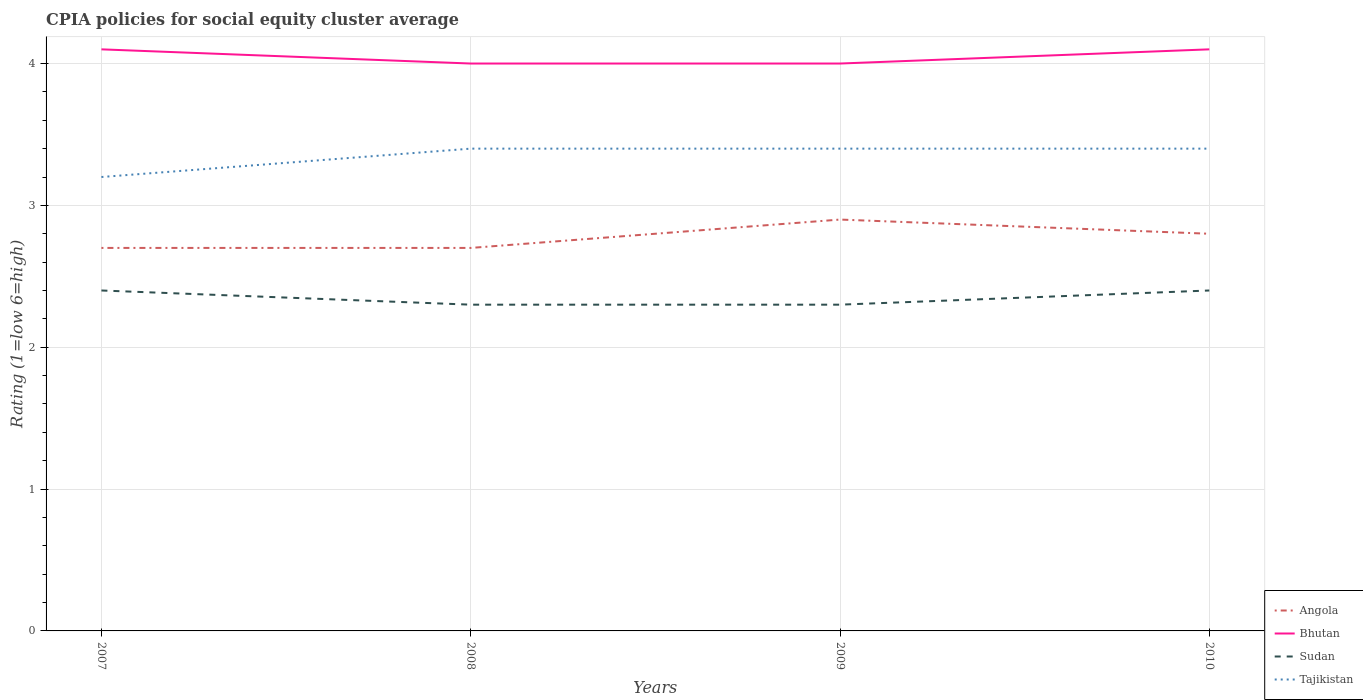How many different coloured lines are there?
Your answer should be compact. 4. Across all years, what is the maximum CPIA rating in Sudan?
Provide a short and direct response. 2.3. What is the total CPIA rating in Angola in the graph?
Make the answer very short. 0. What is the difference between the highest and the second highest CPIA rating in Tajikistan?
Give a very brief answer. 0.2. Is the CPIA rating in Bhutan strictly greater than the CPIA rating in Tajikistan over the years?
Your answer should be very brief. No. Are the values on the major ticks of Y-axis written in scientific E-notation?
Offer a terse response. No. Does the graph contain any zero values?
Your response must be concise. No. Does the graph contain grids?
Ensure brevity in your answer.  Yes. Where does the legend appear in the graph?
Provide a short and direct response. Bottom right. How many legend labels are there?
Your response must be concise. 4. How are the legend labels stacked?
Your answer should be compact. Vertical. What is the title of the graph?
Provide a short and direct response. CPIA policies for social equity cluster average. Does "Ukraine" appear as one of the legend labels in the graph?
Your response must be concise. No. What is the Rating (1=low 6=high) of Sudan in 2007?
Ensure brevity in your answer.  2.4. What is the Rating (1=low 6=high) in Tajikistan in 2007?
Your response must be concise. 3.2. What is the Rating (1=low 6=high) of Bhutan in 2008?
Give a very brief answer. 4. What is the Rating (1=low 6=high) in Sudan in 2008?
Offer a very short reply. 2.3. What is the Rating (1=low 6=high) in Tajikistan in 2008?
Keep it short and to the point. 3.4. What is the Rating (1=low 6=high) in Tajikistan in 2009?
Your answer should be very brief. 3.4. What is the Rating (1=low 6=high) of Angola in 2010?
Your response must be concise. 2.8. What is the Rating (1=low 6=high) of Bhutan in 2010?
Ensure brevity in your answer.  4.1. Across all years, what is the maximum Rating (1=low 6=high) in Angola?
Make the answer very short. 2.9. Across all years, what is the maximum Rating (1=low 6=high) in Bhutan?
Keep it short and to the point. 4.1. Across all years, what is the maximum Rating (1=low 6=high) of Tajikistan?
Ensure brevity in your answer.  3.4. Across all years, what is the minimum Rating (1=low 6=high) in Bhutan?
Keep it short and to the point. 4. Across all years, what is the minimum Rating (1=low 6=high) in Sudan?
Your answer should be compact. 2.3. What is the total Rating (1=low 6=high) of Angola in the graph?
Make the answer very short. 11.1. What is the total Rating (1=low 6=high) in Bhutan in the graph?
Your answer should be compact. 16.2. What is the difference between the Rating (1=low 6=high) in Bhutan in 2007 and that in 2008?
Provide a succinct answer. 0.1. What is the difference between the Rating (1=low 6=high) in Tajikistan in 2007 and that in 2008?
Your answer should be very brief. -0.2. What is the difference between the Rating (1=low 6=high) in Bhutan in 2007 and that in 2009?
Keep it short and to the point. 0.1. What is the difference between the Rating (1=low 6=high) in Sudan in 2007 and that in 2009?
Your answer should be compact. 0.1. What is the difference between the Rating (1=low 6=high) of Sudan in 2007 and that in 2010?
Keep it short and to the point. 0. What is the difference between the Rating (1=low 6=high) in Tajikistan in 2007 and that in 2010?
Provide a short and direct response. -0.2. What is the difference between the Rating (1=low 6=high) in Angola in 2008 and that in 2009?
Offer a terse response. -0.2. What is the difference between the Rating (1=low 6=high) of Sudan in 2008 and that in 2010?
Provide a short and direct response. -0.1. What is the difference between the Rating (1=low 6=high) in Tajikistan in 2008 and that in 2010?
Your answer should be compact. 0. What is the difference between the Rating (1=low 6=high) of Angola in 2009 and that in 2010?
Your response must be concise. 0.1. What is the difference between the Rating (1=low 6=high) in Bhutan in 2009 and that in 2010?
Your answer should be compact. -0.1. What is the difference between the Rating (1=low 6=high) in Sudan in 2009 and that in 2010?
Your answer should be compact. -0.1. What is the difference between the Rating (1=low 6=high) of Tajikistan in 2009 and that in 2010?
Provide a succinct answer. 0. What is the difference between the Rating (1=low 6=high) in Angola in 2007 and the Rating (1=low 6=high) in Sudan in 2008?
Your answer should be compact. 0.4. What is the difference between the Rating (1=low 6=high) in Bhutan in 2007 and the Rating (1=low 6=high) in Sudan in 2008?
Keep it short and to the point. 1.8. What is the difference between the Rating (1=low 6=high) in Bhutan in 2007 and the Rating (1=low 6=high) in Tajikistan in 2008?
Your answer should be very brief. 0.7. What is the difference between the Rating (1=low 6=high) of Angola in 2007 and the Rating (1=low 6=high) of Bhutan in 2009?
Keep it short and to the point. -1.3. What is the difference between the Rating (1=low 6=high) of Angola in 2007 and the Rating (1=low 6=high) of Tajikistan in 2009?
Give a very brief answer. -0.7. What is the difference between the Rating (1=low 6=high) of Sudan in 2007 and the Rating (1=low 6=high) of Tajikistan in 2009?
Make the answer very short. -1. What is the difference between the Rating (1=low 6=high) in Angola in 2007 and the Rating (1=low 6=high) in Bhutan in 2010?
Provide a short and direct response. -1.4. What is the difference between the Rating (1=low 6=high) in Angola in 2007 and the Rating (1=low 6=high) in Sudan in 2010?
Your response must be concise. 0.3. What is the difference between the Rating (1=low 6=high) of Angola in 2007 and the Rating (1=low 6=high) of Tajikistan in 2010?
Provide a short and direct response. -0.7. What is the difference between the Rating (1=low 6=high) in Bhutan in 2007 and the Rating (1=low 6=high) in Sudan in 2010?
Give a very brief answer. 1.7. What is the difference between the Rating (1=low 6=high) in Bhutan in 2007 and the Rating (1=low 6=high) in Tajikistan in 2010?
Your answer should be very brief. 0.7. What is the difference between the Rating (1=low 6=high) in Angola in 2008 and the Rating (1=low 6=high) in Bhutan in 2009?
Give a very brief answer. -1.3. What is the difference between the Rating (1=low 6=high) in Angola in 2008 and the Rating (1=low 6=high) in Tajikistan in 2009?
Make the answer very short. -0.7. What is the difference between the Rating (1=low 6=high) of Bhutan in 2008 and the Rating (1=low 6=high) of Sudan in 2009?
Give a very brief answer. 1.7. What is the difference between the Rating (1=low 6=high) of Bhutan in 2008 and the Rating (1=low 6=high) of Tajikistan in 2009?
Your response must be concise. 0.6. What is the difference between the Rating (1=low 6=high) in Sudan in 2008 and the Rating (1=low 6=high) in Tajikistan in 2009?
Your answer should be compact. -1.1. What is the difference between the Rating (1=low 6=high) in Angola in 2008 and the Rating (1=low 6=high) in Bhutan in 2010?
Your answer should be compact. -1.4. What is the difference between the Rating (1=low 6=high) of Angola in 2008 and the Rating (1=low 6=high) of Tajikistan in 2010?
Your answer should be compact. -0.7. What is the difference between the Rating (1=low 6=high) in Bhutan in 2008 and the Rating (1=low 6=high) in Sudan in 2010?
Your response must be concise. 1.6. What is the difference between the Rating (1=low 6=high) in Bhutan in 2008 and the Rating (1=low 6=high) in Tajikistan in 2010?
Your answer should be compact. 0.6. What is the difference between the Rating (1=low 6=high) in Sudan in 2008 and the Rating (1=low 6=high) in Tajikistan in 2010?
Keep it short and to the point. -1.1. What is the difference between the Rating (1=low 6=high) of Angola in 2009 and the Rating (1=low 6=high) of Sudan in 2010?
Give a very brief answer. 0.5. What is the difference between the Rating (1=low 6=high) of Bhutan in 2009 and the Rating (1=low 6=high) of Sudan in 2010?
Your answer should be compact. 1.6. What is the difference between the Rating (1=low 6=high) in Bhutan in 2009 and the Rating (1=low 6=high) in Tajikistan in 2010?
Ensure brevity in your answer.  0.6. What is the difference between the Rating (1=low 6=high) of Sudan in 2009 and the Rating (1=low 6=high) of Tajikistan in 2010?
Offer a very short reply. -1.1. What is the average Rating (1=low 6=high) of Angola per year?
Offer a terse response. 2.77. What is the average Rating (1=low 6=high) of Bhutan per year?
Provide a succinct answer. 4.05. What is the average Rating (1=low 6=high) of Sudan per year?
Provide a short and direct response. 2.35. What is the average Rating (1=low 6=high) of Tajikistan per year?
Give a very brief answer. 3.35. In the year 2007, what is the difference between the Rating (1=low 6=high) of Angola and Rating (1=low 6=high) of Bhutan?
Offer a very short reply. -1.4. In the year 2007, what is the difference between the Rating (1=low 6=high) in Angola and Rating (1=low 6=high) in Sudan?
Your answer should be very brief. 0.3. In the year 2007, what is the difference between the Rating (1=low 6=high) in Angola and Rating (1=low 6=high) in Tajikistan?
Your response must be concise. -0.5. In the year 2007, what is the difference between the Rating (1=low 6=high) of Bhutan and Rating (1=low 6=high) of Tajikistan?
Give a very brief answer. 0.9. In the year 2008, what is the difference between the Rating (1=low 6=high) in Angola and Rating (1=low 6=high) in Bhutan?
Your answer should be very brief. -1.3. In the year 2008, what is the difference between the Rating (1=low 6=high) of Angola and Rating (1=low 6=high) of Sudan?
Your response must be concise. 0.4. In the year 2008, what is the difference between the Rating (1=low 6=high) in Angola and Rating (1=low 6=high) in Tajikistan?
Your answer should be compact. -0.7. In the year 2008, what is the difference between the Rating (1=low 6=high) of Bhutan and Rating (1=low 6=high) of Sudan?
Offer a very short reply. 1.7. In the year 2008, what is the difference between the Rating (1=low 6=high) of Sudan and Rating (1=low 6=high) of Tajikistan?
Keep it short and to the point. -1.1. In the year 2009, what is the difference between the Rating (1=low 6=high) in Angola and Rating (1=low 6=high) in Bhutan?
Your answer should be very brief. -1.1. In the year 2009, what is the difference between the Rating (1=low 6=high) in Bhutan and Rating (1=low 6=high) in Tajikistan?
Make the answer very short. 0.6. What is the ratio of the Rating (1=low 6=high) of Angola in 2007 to that in 2008?
Ensure brevity in your answer.  1. What is the ratio of the Rating (1=low 6=high) of Sudan in 2007 to that in 2008?
Provide a short and direct response. 1.04. What is the ratio of the Rating (1=low 6=high) of Tajikistan in 2007 to that in 2008?
Give a very brief answer. 0.94. What is the ratio of the Rating (1=low 6=high) of Angola in 2007 to that in 2009?
Your response must be concise. 0.93. What is the ratio of the Rating (1=low 6=high) in Sudan in 2007 to that in 2009?
Ensure brevity in your answer.  1.04. What is the ratio of the Rating (1=low 6=high) in Tajikistan in 2007 to that in 2009?
Keep it short and to the point. 0.94. What is the ratio of the Rating (1=low 6=high) of Angola in 2008 to that in 2009?
Provide a short and direct response. 0.93. What is the ratio of the Rating (1=low 6=high) in Bhutan in 2008 to that in 2010?
Make the answer very short. 0.98. What is the ratio of the Rating (1=low 6=high) of Sudan in 2008 to that in 2010?
Give a very brief answer. 0.96. What is the ratio of the Rating (1=low 6=high) in Tajikistan in 2008 to that in 2010?
Provide a short and direct response. 1. What is the ratio of the Rating (1=low 6=high) of Angola in 2009 to that in 2010?
Give a very brief answer. 1.04. What is the ratio of the Rating (1=low 6=high) of Bhutan in 2009 to that in 2010?
Offer a terse response. 0.98. What is the ratio of the Rating (1=low 6=high) of Tajikistan in 2009 to that in 2010?
Your answer should be compact. 1. What is the difference between the highest and the second highest Rating (1=low 6=high) in Angola?
Offer a very short reply. 0.1. What is the difference between the highest and the second highest Rating (1=low 6=high) of Bhutan?
Give a very brief answer. 0. What is the difference between the highest and the second highest Rating (1=low 6=high) of Tajikistan?
Offer a very short reply. 0. What is the difference between the highest and the lowest Rating (1=low 6=high) of Angola?
Your answer should be very brief. 0.2. What is the difference between the highest and the lowest Rating (1=low 6=high) in Sudan?
Ensure brevity in your answer.  0.1. What is the difference between the highest and the lowest Rating (1=low 6=high) of Tajikistan?
Your response must be concise. 0.2. 